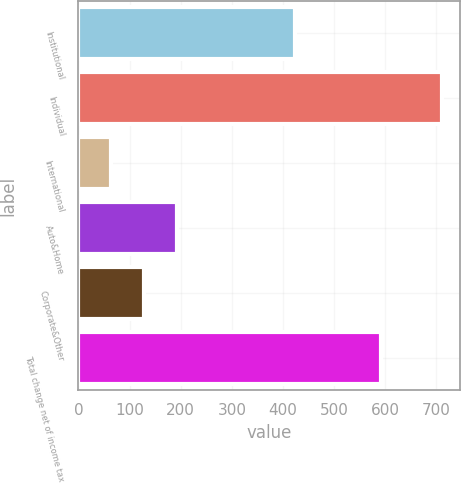Convert chart. <chart><loc_0><loc_0><loc_500><loc_500><bar_chart><fcel>Institutional<fcel>Individual<fcel>International<fcel>Auto&Home<fcel>Corporate&Other<fcel>Total change net of income tax<nl><fcel>423<fcel>711<fcel>64<fcel>193.4<fcel>128.7<fcel>592<nl></chart> 